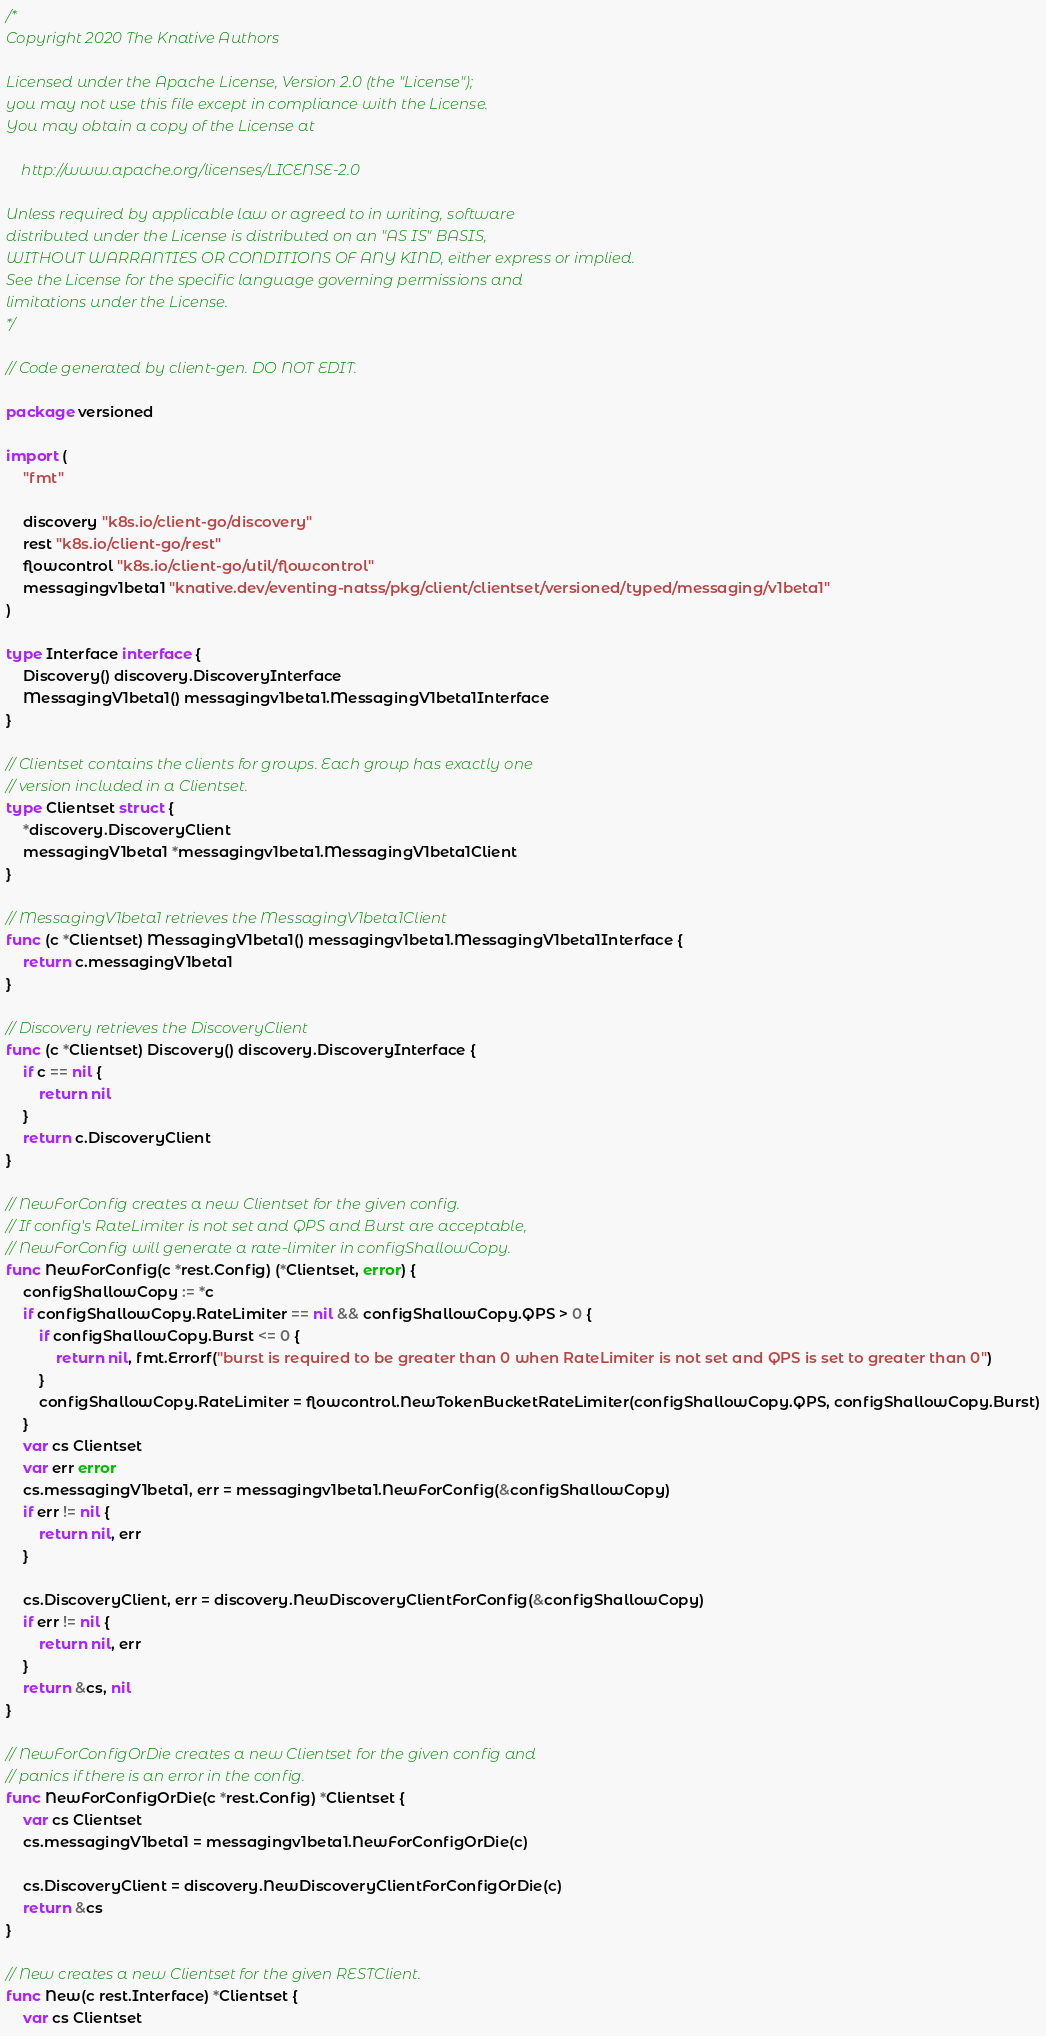<code> <loc_0><loc_0><loc_500><loc_500><_Go_>/*
Copyright 2020 The Knative Authors

Licensed under the Apache License, Version 2.0 (the "License");
you may not use this file except in compliance with the License.
You may obtain a copy of the License at

    http://www.apache.org/licenses/LICENSE-2.0

Unless required by applicable law or agreed to in writing, software
distributed under the License is distributed on an "AS IS" BASIS,
WITHOUT WARRANTIES OR CONDITIONS OF ANY KIND, either express or implied.
See the License for the specific language governing permissions and
limitations under the License.
*/

// Code generated by client-gen. DO NOT EDIT.

package versioned

import (
	"fmt"

	discovery "k8s.io/client-go/discovery"
	rest "k8s.io/client-go/rest"
	flowcontrol "k8s.io/client-go/util/flowcontrol"
	messagingv1beta1 "knative.dev/eventing-natss/pkg/client/clientset/versioned/typed/messaging/v1beta1"
)

type Interface interface {
	Discovery() discovery.DiscoveryInterface
	MessagingV1beta1() messagingv1beta1.MessagingV1beta1Interface
}

// Clientset contains the clients for groups. Each group has exactly one
// version included in a Clientset.
type Clientset struct {
	*discovery.DiscoveryClient
	messagingV1beta1 *messagingv1beta1.MessagingV1beta1Client
}

// MessagingV1beta1 retrieves the MessagingV1beta1Client
func (c *Clientset) MessagingV1beta1() messagingv1beta1.MessagingV1beta1Interface {
	return c.messagingV1beta1
}

// Discovery retrieves the DiscoveryClient
func (c *Clientset) Discovery() discovery.DiscoveryInterface {
	if c == nil {
		return nil
	}
	return c.DiscoveryClient
}

// NewForConfig creates a new Clientset for the given config.
// If config's RateLimiter is not set and QPS and Burst are acceptable,
// NewForConfig will generate a rate-limiter in configShallowCopy.
func NewForConfig(c *rest.Config) (*Clientset, error) {
	configShallowCopy := *c
	if configShallowCopy.RateLimiter == nil && configShallowCopy.QPS > 0 {
		if configShallowCopy.Burst <= 0 {
			return nil, fmt.Errorf("burst is required to be greater than 0 when RateLimiter is not set and QPS is set to greater than 0")
		}
		configShallowCopy.RateLimiter = flowcontrol.NewTokenBucketRateLimiter(configShallowCopy.QPS, configShallowCopy.Burst)
	}
	var cs Clientset
	var err error
	cs.messagingV1beta1, err = messagingv1beta1.NewForConfig(&configShallowCopy)
	if err != nil {
		return nil, err
	}

	cs.DiscoveryClient, err = discovery.NewDiscoveryClientForConfig(&configShallowCopy)
	if err != nil {
		return nil, err
	}
	return &cs, nil
}

// NewForConfigOrDie creates a new Clientset for the given config and
// panics if there is an error in the config.
func NewForConfigOrDie(c *rest.Config) *Clientset {
	var cs Clientset
	cs.messagingV1beta1 = messagingv1beta1.NewForConfigOrDie(c)

	cs.DiscoveryClient = discovery.NewDiscoveryClientForConfigOrDie(c)
	return &cs
}

// New creates a new Clientset for the given RESTClient.
func New(c rest.Interface) *Clientset {
	var cs Clientset</code> 